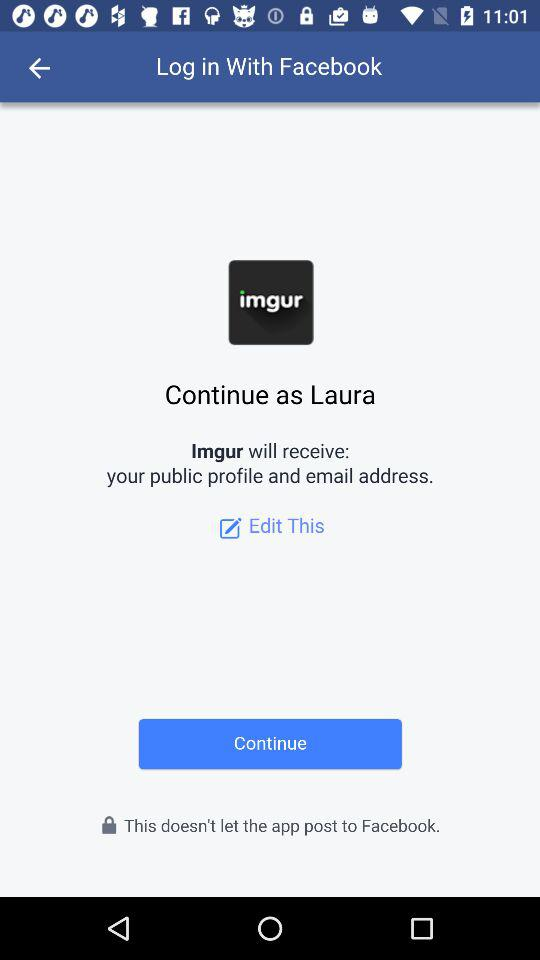What application is asking for permission? The application that is asking for permission is "Imgur". 